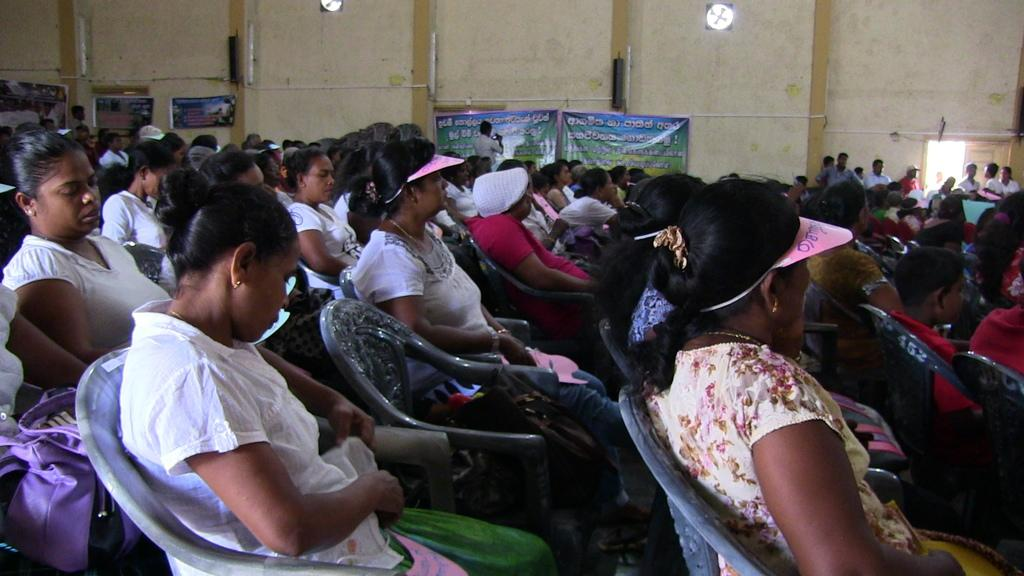What is the setting of the image? The setting of the image is an open hall with people seated on chairs. What can be seen at the entrance of the hall? There are people standing at the entrance. What is on the walls of the hall? There are posters on the wall. Can you describe the posters in more detail? Some of the posters have semi-caps. How does the comfort of the chairs affect the people's ability to act in the image? The comfort of the chairs is not mentioned in the image, and therefore it cannot be determined how it affects the people's ability to act. 